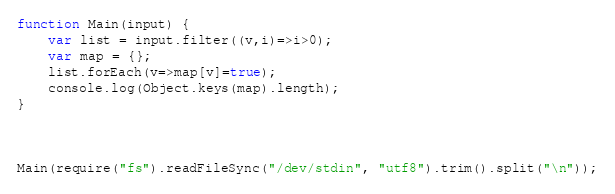<code> <loc_0><loc_0><loc_500><loc_500><_JavaScript_>function Main(input) {
    var list = input.filter((v,i)=>i>0);
    var map = {};
    list.forEach(v=>map[v]=true);
    console.log(Object.keys(map).length);
}



Main(require("fs").readFileSync("/dev/stdin", "utf8").trim().split("\n"));</code> 